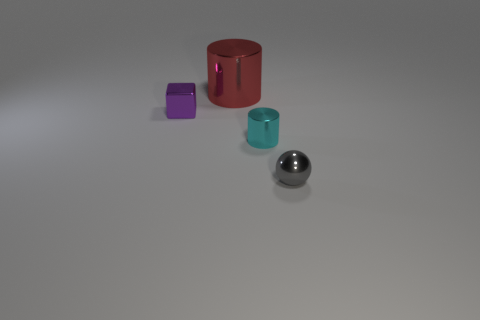Add 3 gray things. How many objects exist? 7 Subtract all spheres. How many objects are left? 3 Add 4 gray shiny spheres. How many gray shiny spheres exist? 5 Subtract 0 red blocks. How many objects are left? 4 Subtract all small metal spheres. Subtract all shiny balls. How many objects are left? 2 Add 1 cyan metal objects. How many cyan metal objects are left? 2 